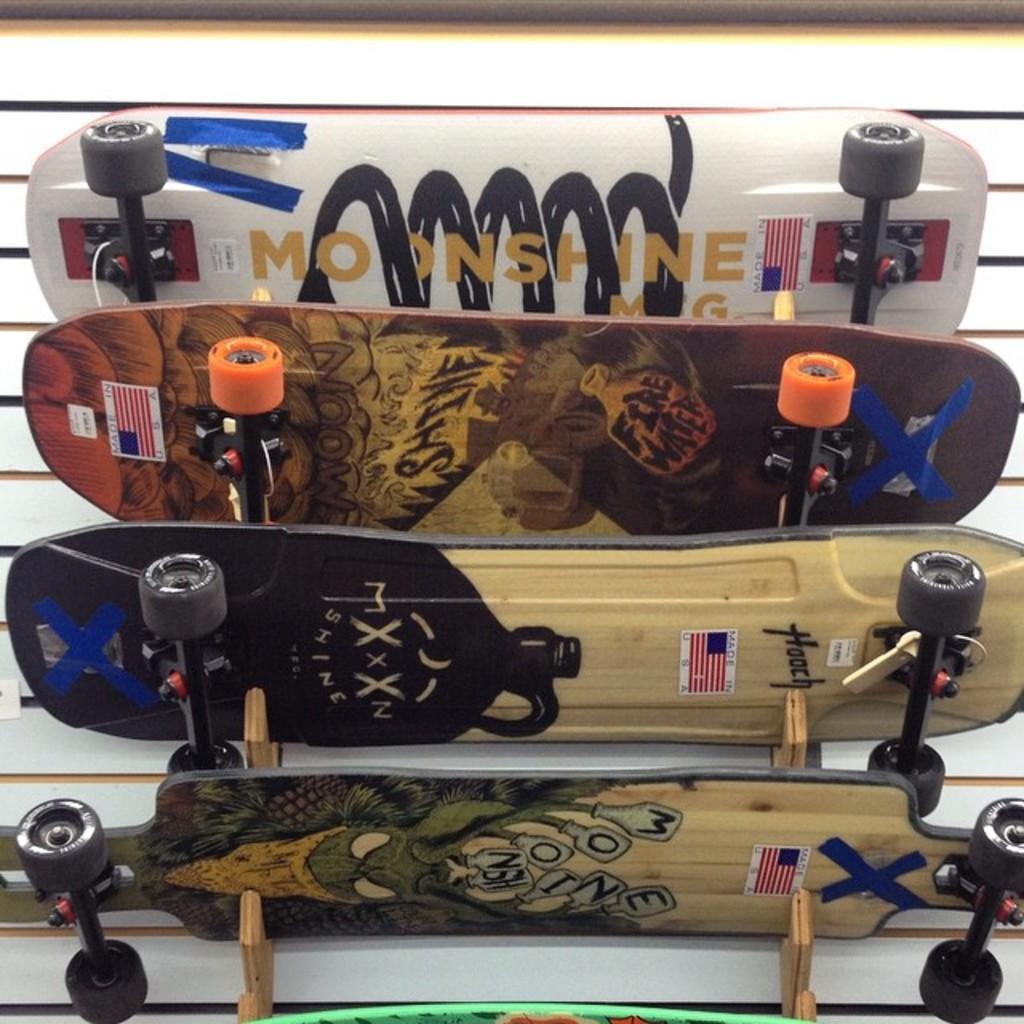In one or two sentences, can you explain what this image depicts? These are the 4 skateboards, at the top it is in white color. 